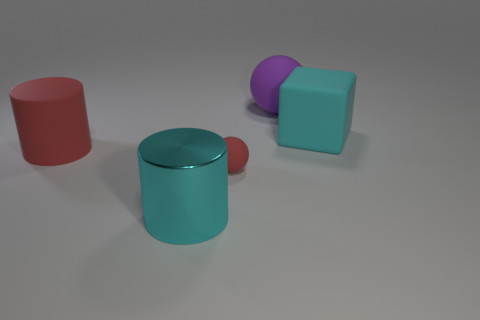Add 2 large purple matte spheres. How many objects exist? 7 Subtract all spheres. How many objects are left? 3 Subtract all metallic objects. Subtract all red spheres. How many objects are left? 3 Add 3 cyan metallic cylinders. How many cyan metallic cylinders are left? 4 Add 4 purple cylinders. How many purple cylinders exist? 4 Subtract 0 green cylinders. How many objects are left? 5 Subtract all brown cylinders. Subtract all yellow balls. How many cylinders are left? 2 